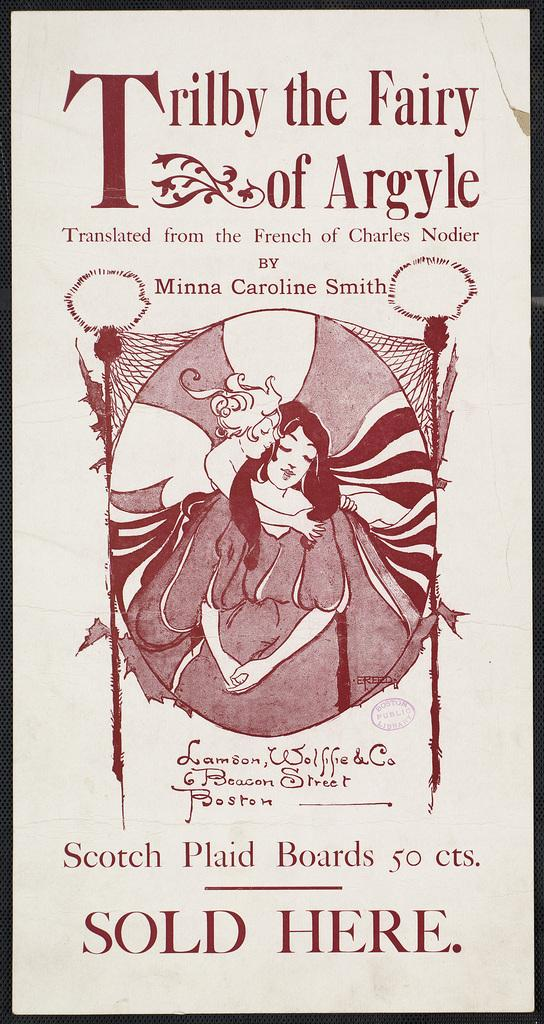<image>
Provide a brief description of the given image. A poster advertising Trilby the Fairy of Argyle. 